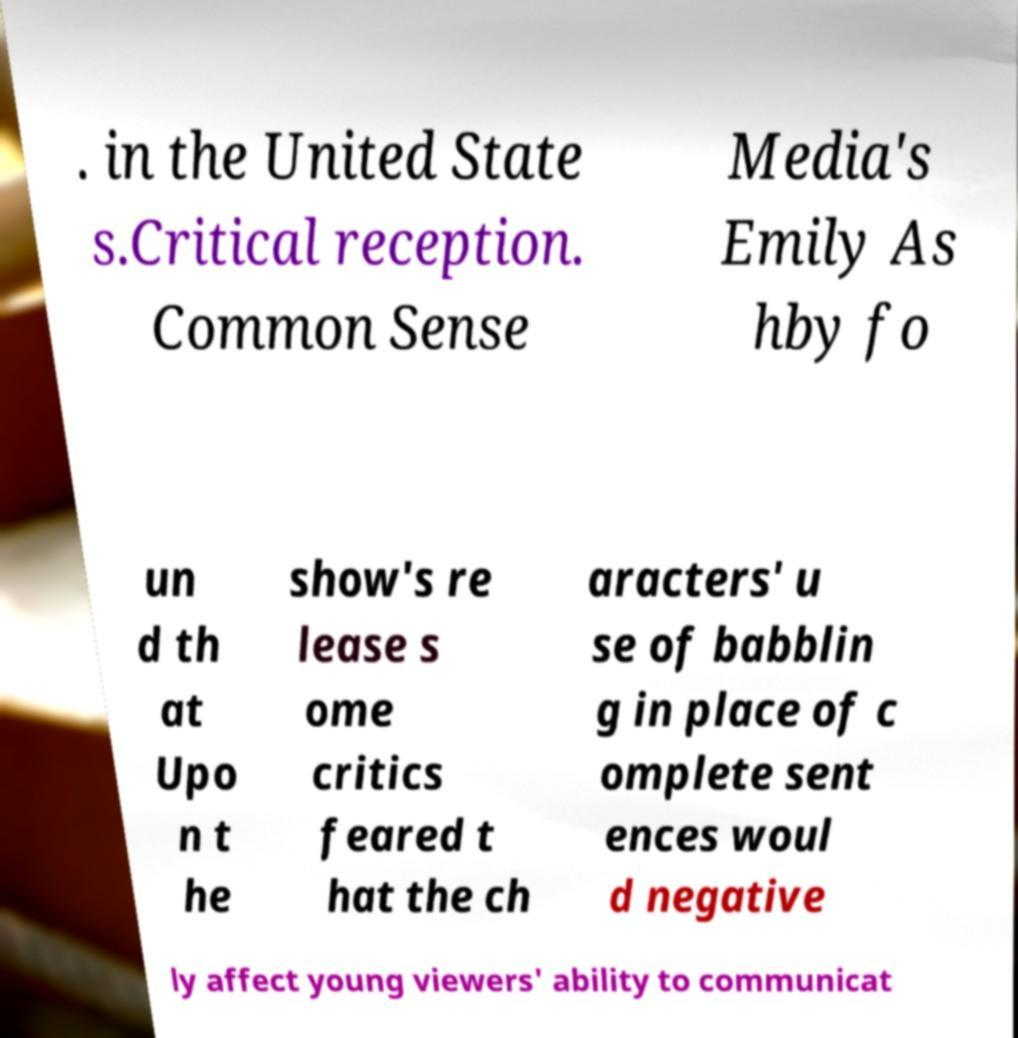There's text embedded in this image that I need extracted. Can you transcribe it verbatim? . in the United State s.Critical reception. Common Sense Media's Emily As hby fo un d th at Upo n t he show's re lease s ome critics feared t hat the ch aracters' u se of babblin g in place of c omplete sent ences woul d negative ly affect young viewers' ability to communicat 